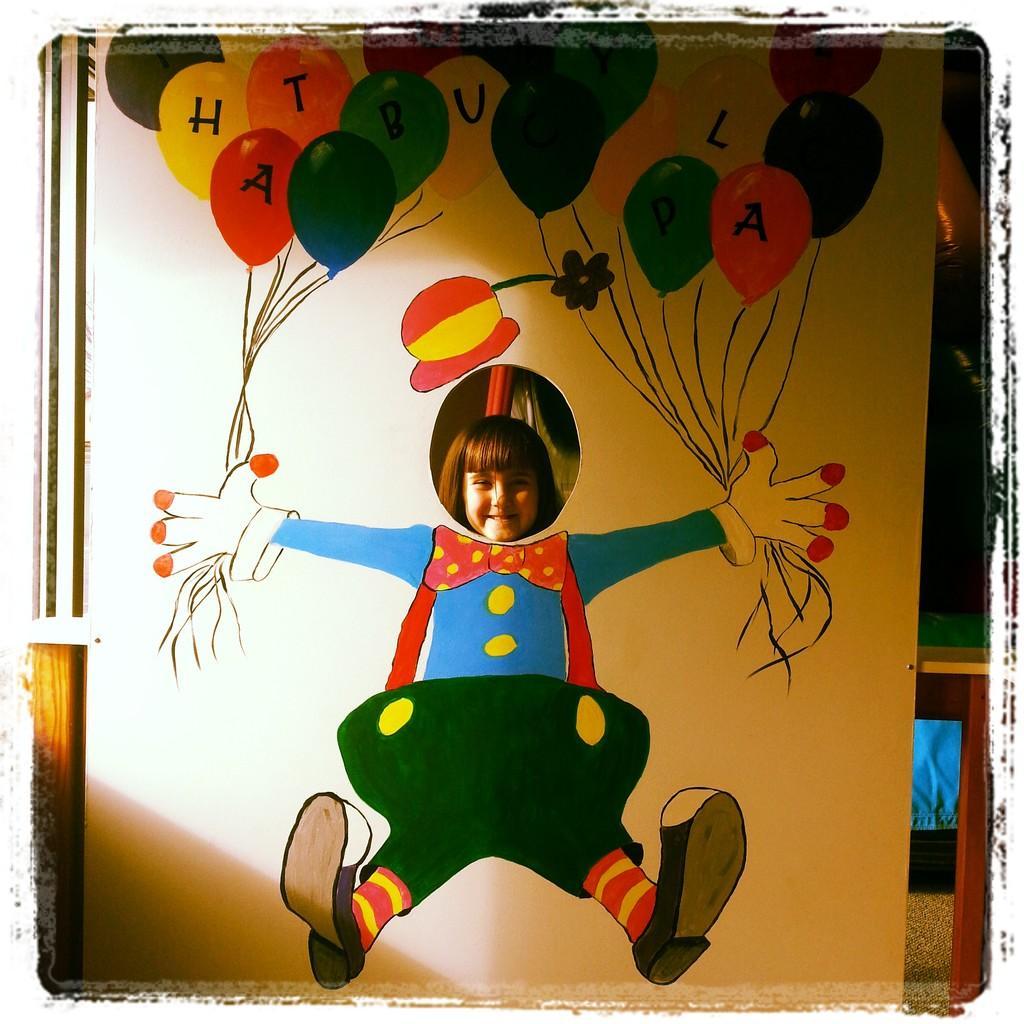Could you give a brief overview of what you see in this image? This is an edited image. In the center we can see the drawing of balloons and the drawing of a person on an object. In the background we can see the head of a person and we can see the table and some other objects. 